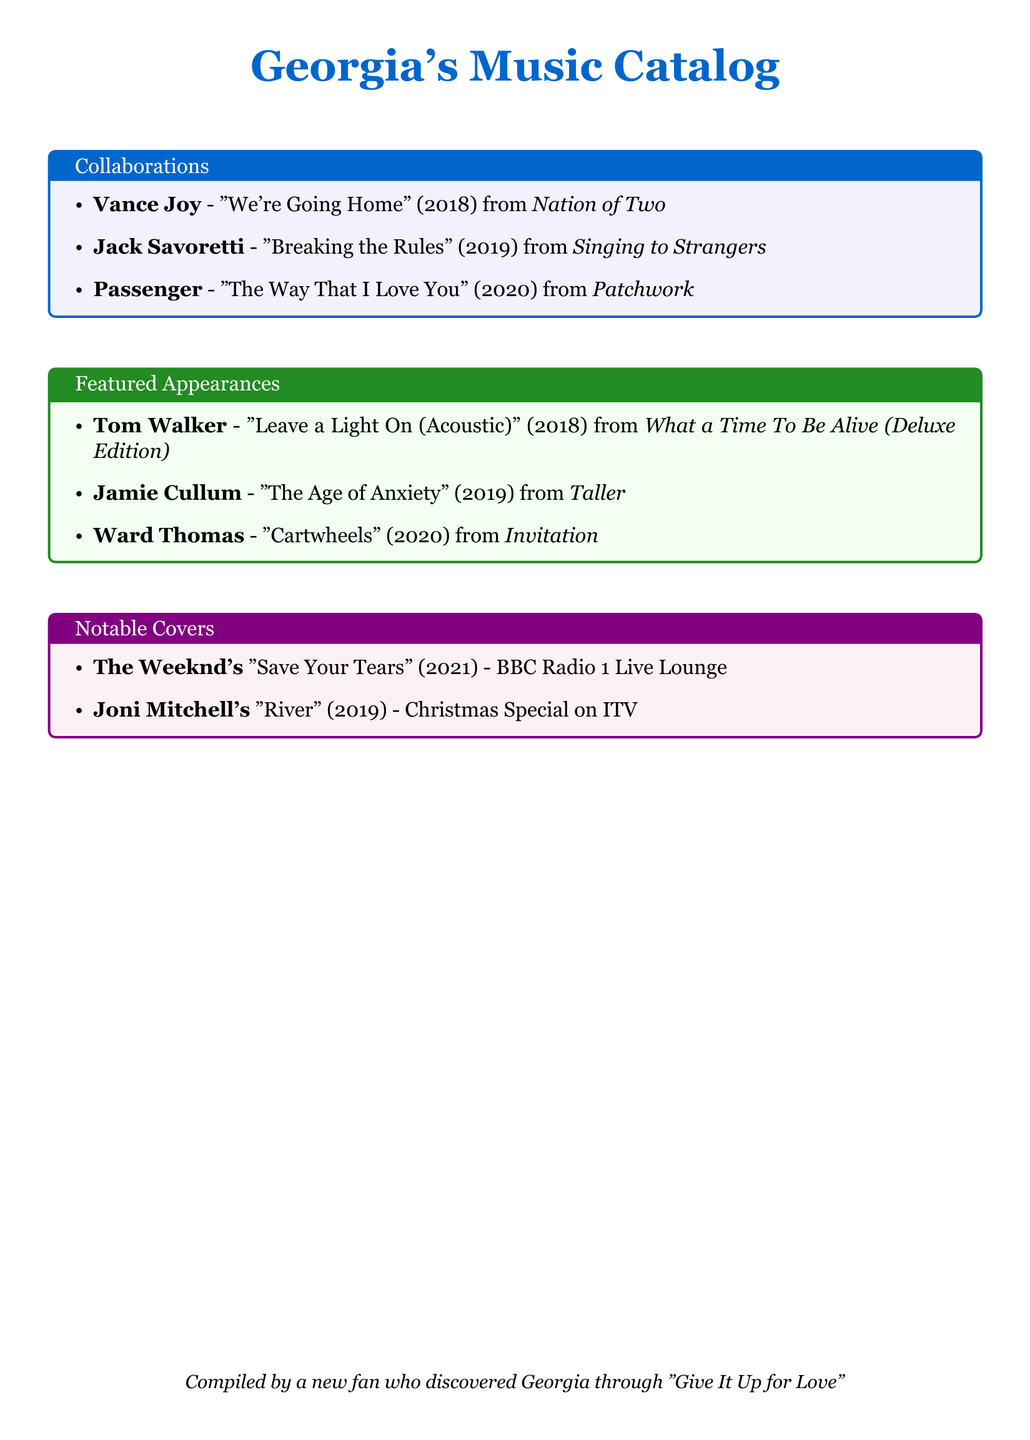what is the name of the collaboration with Vance Joy? The collaboration is titled "We're Going Home" and it features Vance Joy.
Answer: "We're Going Home" what year was Jack Savoretti's "Breaking the Rules" released? Jack Savoretti's "Breaking the Rules" was released in 2019.
Answer: 2019 who is featured on "Leave a Light On (Acoustic)"? The artist featured on "Leave a Light On (Acoustic)" is Tom Walker.
Answer: Tom Walker how many songs are listed under "Notable Covers"? There are two songs listed under "Notable Covers."
Answer: 2 what is the title of Passenger's collaboration with Georgia? Passenger's collaboration is titled "The Way That I Love You."
Answer: "The Way That I Love You" which song by Joni Mitchell is covered by Georgia? Georgia covers Joni Mitchell's song "River."
Answer: "River" who is the collaborating artist on "Cartwheels"? The collaborating artist on "Cartwheels" is Ward Thomas.
Answer: Ward Thomas what type of document is this? This document is a catalog of Georgia's music collaborations and featured appearances.
Answer: catalog 